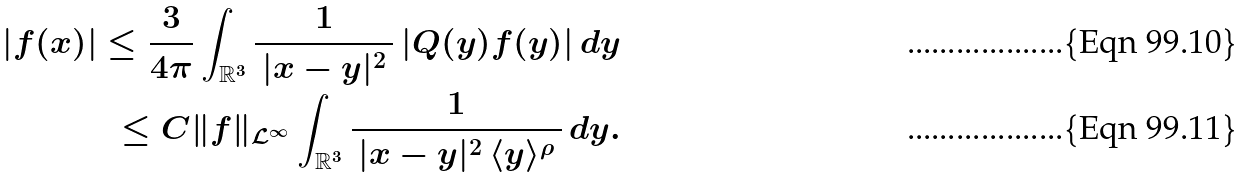<formula> <loc_0><loc_0><loc_500><loc_500>| f ( x ) | \leq \frac { 3 } { 4 \pi } \int _ { { \mathbb { R } } ^ { 3 } } \frac { 1 } { \, | x - y | ^ { 2 } \, } \, | Q ( y ) f ( y ) | \, d y \\ \leq C \| f \| _ { { \mathcal { L } } ^ { \infty } } \int _ { { \mathbb { R } } ^ { 3 } } \frac { 1 } { \, | x - y | ^ { 2 } \, \langle y \rangle ^ { \rho } \, } \, d y .</formula> 